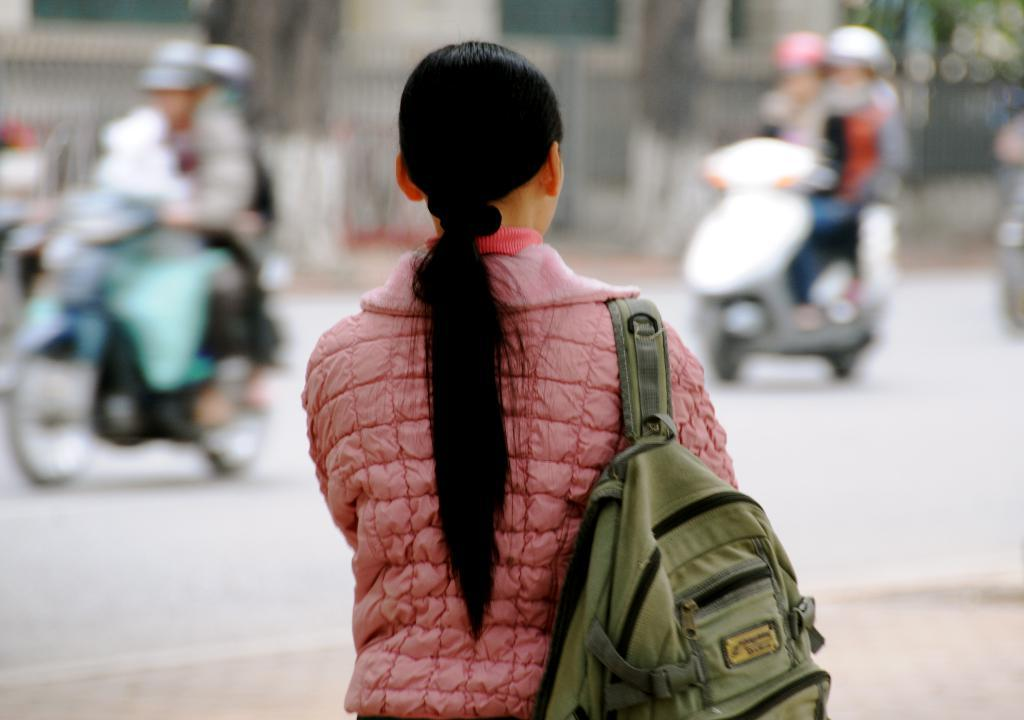Who is the main subject in the image? There is a woman in the image. What is the woman doing in the image? The woman is walking on the road. What is the woman wearing in the image? The woman is wearing a pink jacket. What is the woman carrying in the image? The woman is carrying a bag. What is the hairstyle of the woman in the image? The woman has a ponytail. What can be seen in the background of the image? There are vehicles running on the road in the background of the image. What type of brush is the woman using to paint the card in the image? There is no brush or card present in the image; the woman is walking on the road and wearing a pink jacket. 